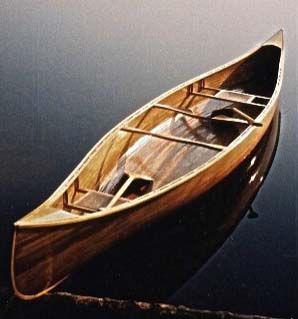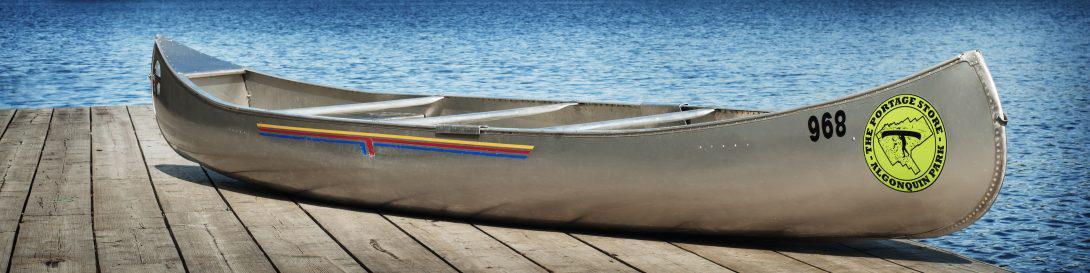The first image is the image on the left, the second image is the image on the right. Assess this claim about the two images: "One image shows at least three empty red canoes parked close together on water, and the other image includes at least one oar.". Correct or not? Answer yes or no. No. 